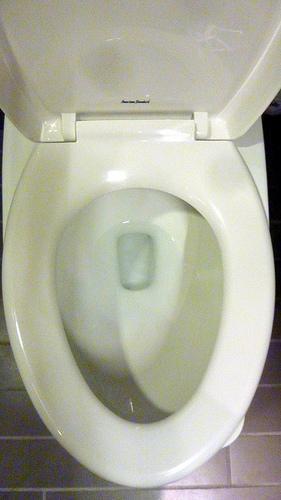How many toilets are there?
Give a very brief answer. 1. 